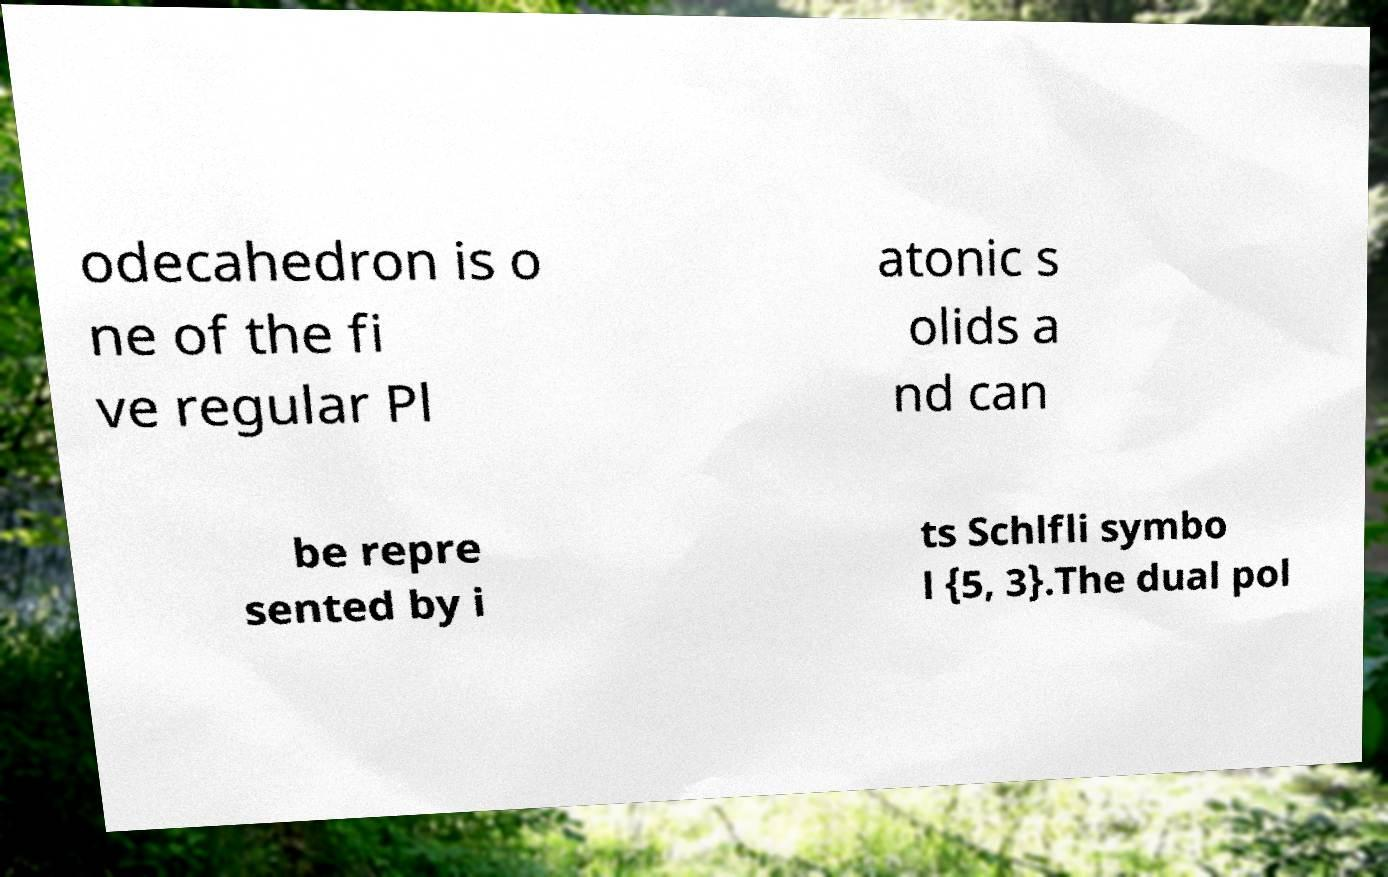What messages or text are displayed in this image? I need them in a readable, typed format. odecahedron is o ne of the fi ve regular Pl atonic s olids a nd can be repre sented by i ts Schlfli symbo l {5, 3}.The dual pol 